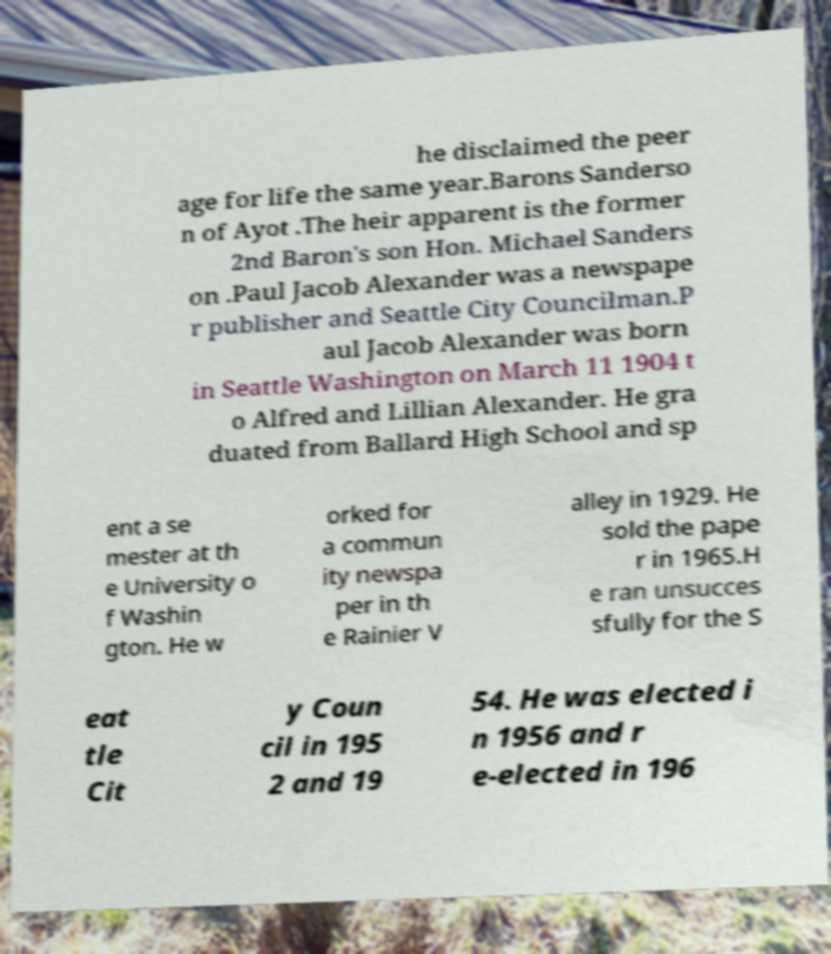I need the written content from this picture converted into text. Can you do that? he disclaimed the peer age for life the same year.Barons Sanderso n of Ayot .The heir apparent is the former 2nd Baron's son Hon. Michael Sanders on .Paul Jacob Alexander was a newspape r publisher and Seattle City Councilman.P aul Jacob Alexander was born in Seattle Washington on March 11 1904 t o Alfred and Lillian Alexander. He gra duated from Ballard High School and sp ent a se mester at th e University o f Washin gton. He w orked for a commun ity newspa per in th e Rainier V alley in 1929. He sold the pape r in 1965.H e ran unsucces sfully for the S eat tle Cit y Coun cil in 195 2 and 19 54. He was elected i n 1956 and r e-elected in 196 